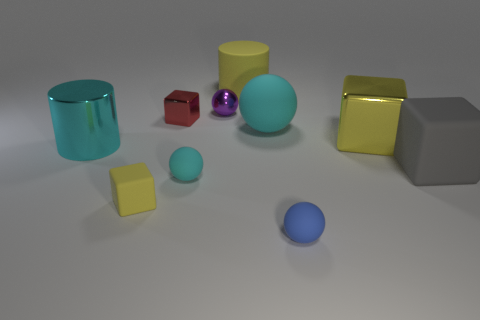Are the big yellow object left of the tiny blue object and the cylinder in front of the big matte cylinder made of the same material?
Give a very brief answer. No. There is a small object that is the same color as the big matte sphere; what is its shape?
Your response must be concise. Sphere. How many things are either cyan things that are behind the cyan cylinder or rubber things right of the metallic ball?
Provide a succinct answer. 4. There is a rubber sphere behind the cyan metallic cylinder; does it have the same color as the small rubber thing right of the large yellow cylinder?
Provide a succinct answer. No. What shape is the metal thing that is both in front of the purple ball and right of the small metal block?
Keep it short and to the point. Cube. What is the color of the other block that is the same size as the gray cube?
Your response must be concise. Yellow. Are there any big matte objects of the same color as the large matte block?
Give a very brief answer. No. There is a metallic cube left of the tiny shiny ball; does it have the same size as the matte object that is left of the red metal thing?
Your answer should be very brief. Yes. What is the material of the small sphere that is both in front of the tiny red object and to the left of the small blue rubber thing?
Provide a short and direct response. Rubber. There is a metallic object that is the same color as the big matte cylinder; what is its size?
Make the answer very short. Large. 